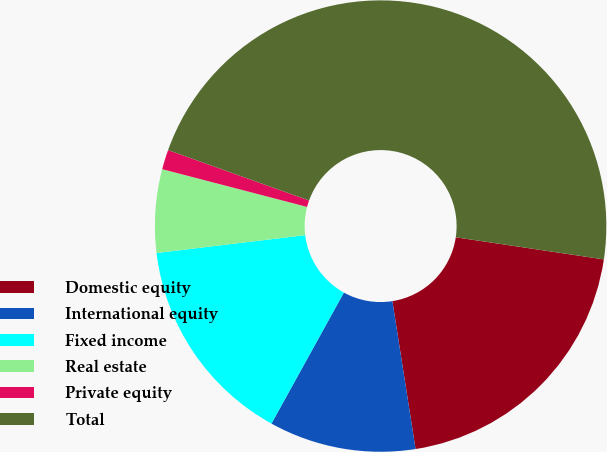Convert chart. <chart><loc_0><loc_0><loc_500><loc_500><pie_chart><fcel>Domestic equity<fcel>International equity<fcel>Fixed income<fcel>Real estate<fcel>Private equity<fcel>Total<nl><fcel>20.17%<fcel>10.51%<fcel>15.06%<fcel>5.96%<fcel>1.41%<fcel>46.9%<nl></chart> 